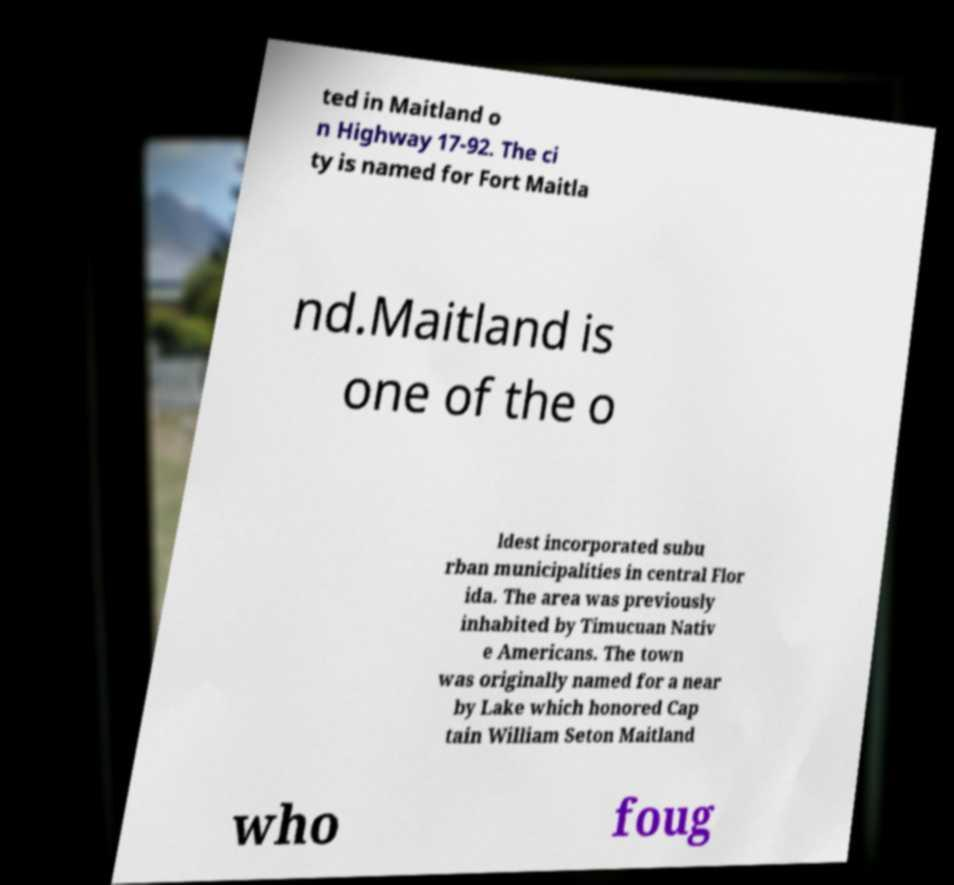What messages or text are displayed in this image? I need them in a readable, typed format. ted in Maitland o n Highway 17-92. The ci ty is named for Fort Maitla nd.Maitland is one of the o ldest incorporated subu rban municipalities in central Flor ida. The area was previously inhabited by Timucuan Nativ e Americans. The town was originally named for a near by Lake which honored Cap tain William Seton Maitland who foug 